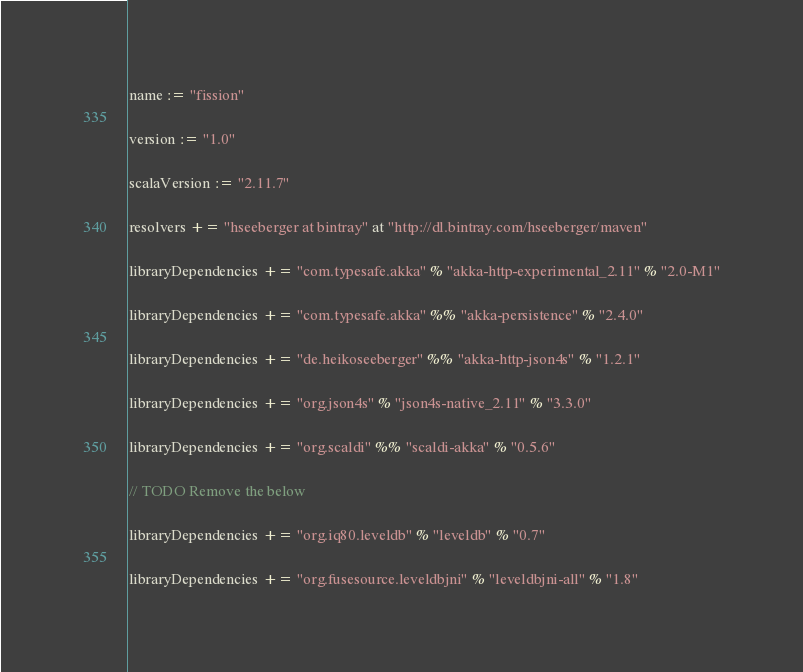Convert code to text. <code><loc_0><loc_0><loc_500><loc_500><_Scala_>name := "fission"

version := "1.0"

scalaVersion := "2.11.7"

resolvers += "hseeberger at bintray" at "http://dl.bintray.com/hseeberger/maven"

libraryDependencies += "com.typesafe.akka" % "akka-http-experimental_2.11" % "2.0-M1"

libraryDependencies += "com.typesafe.akka" %% "akka-persistence" % "2.4.0"

libraryDependencies += "de.heikoseeberger" %% "akka-http-json4s" % "1.2.1"

libraryDependencies += "org.json4s" % "json4s-native_2.11" % "3.3.0"

libraryDependencies += "org.scaldi" %% "scaldi-akka" % "0.5.6"

// TODO Remove the below

libraryDependencies += "org.iq80.leveldb" % "leveldb" % "0.7"

libraryDependencies += "org.fusesource.leveldbjni" % "leveldbjni-all" % "1.8"
</code> 